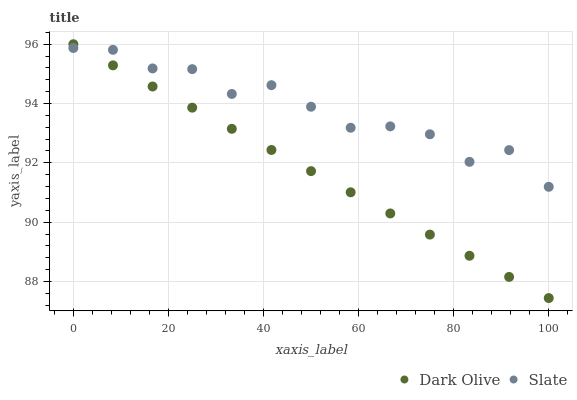Does Dark Olive have the minimum area under the curve?
Answer yes or no. Yes. Does Slate have the maximum area under the curve?
Answer yes or no. Yes. Does Dark Olive have the maximum area under the curve?
Answer yes or no. No. Is Dark Olive the smoothest?
Answer yes or no. Yes. Is Slate the roughest?
Answer yes or no. Yes. Is Dark Olive the roughest?
Answer yes or no. No. Does Dark Olive have the lowest value?
Answer yes or no. Yes. Does Dark Olive have the highest value?
Answer yes or no. Yes. Does Slate intersect Dark Olive?
Answer yes or no. Yes. Is Slate less than Dark Olive?
Answer yes or no. No. Is Slate greater than Dark Olive?
Answer yes or no. No. 